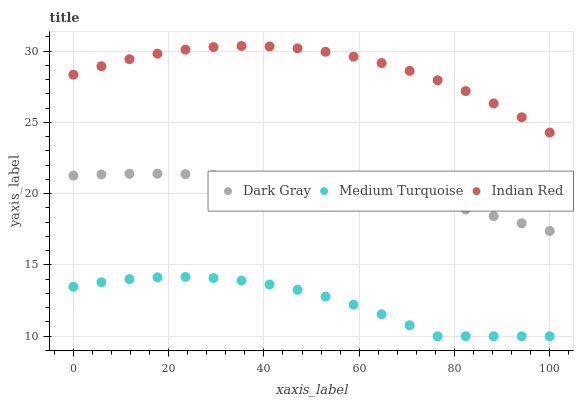Does Medium Turquoise have the minimum area under the curve?
Answer yes or no. Yes. Does Indian Red have the maximum area under the curve?
Answer yes or no. Yes. Does Indian Red have the minimum area under the curve?
Answer yes or no. No. Does Medium Turquoise have the maximum area under the curve?
Answer yes or no. No. Is Dark Gray the smoothest?
Answer yes or no. Yes. Is Medium Turquoise the roughest?
Answer yes or no. Yes. Is Indian Red the smoothest?
Answer yes or no. No. Is Indian Red the roughest?
Answer yes or no. No. Does Medium Turquoise have the lowest value?
Answer yes or no. Yes. Does Indian Red have the lowest value?
Answer yes or no. No. Does Indian Red have the highest value?
Answer yes or no. Yes. Does Medium Turquoise have the highest value?
Answer yes or no. No. Is Medium Turquoise less than Indian Red?
Answer yes or no. Yes. Is Indian Red greater than Medium Turquoise?
Answer yes or no. Yes. Does Medium Turquoise intersect Indian Red?
Answer yes or no. No. 